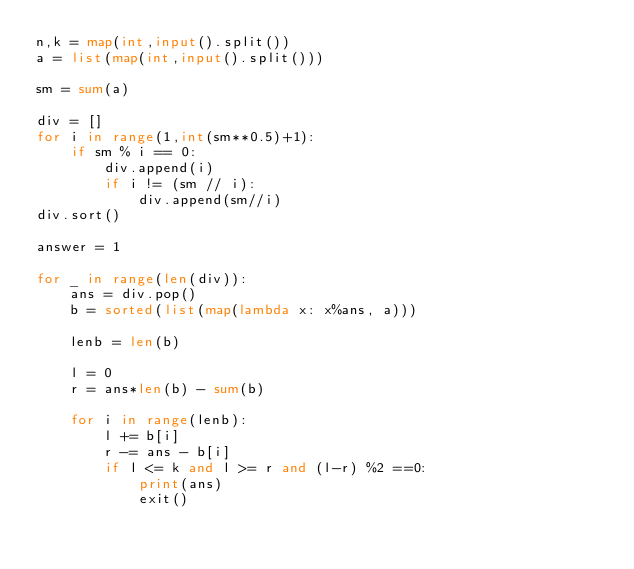Convert code to text. <code><loc_0><loc_0><loc_500><loc_500><_Python_>n,k = map(int,input().split())
a = list(map(int,input().split()))

sm = sum(a)

div = []
for i in range(1,int(sm**0.5)+1):
    if sm % i == 0:
        div.append(i)
        if i != (sm // i):
            div.append(sm//i)
div.sort()

answer = 1

for _ in range(len(div)):
    ans = div.pop()
    b = sorted(list(map(lambda x: x%ans, a)))

    lenb = len(b)
   
    l = 0
    r = ans*len(b) - sum(b)

    for i in range(lenb):
        l += b[i]
        r -= ans - b[i]
        if l <= k and l >= r and (l-r) %2 ==0:
            print(ans)
            exit()
</code> 